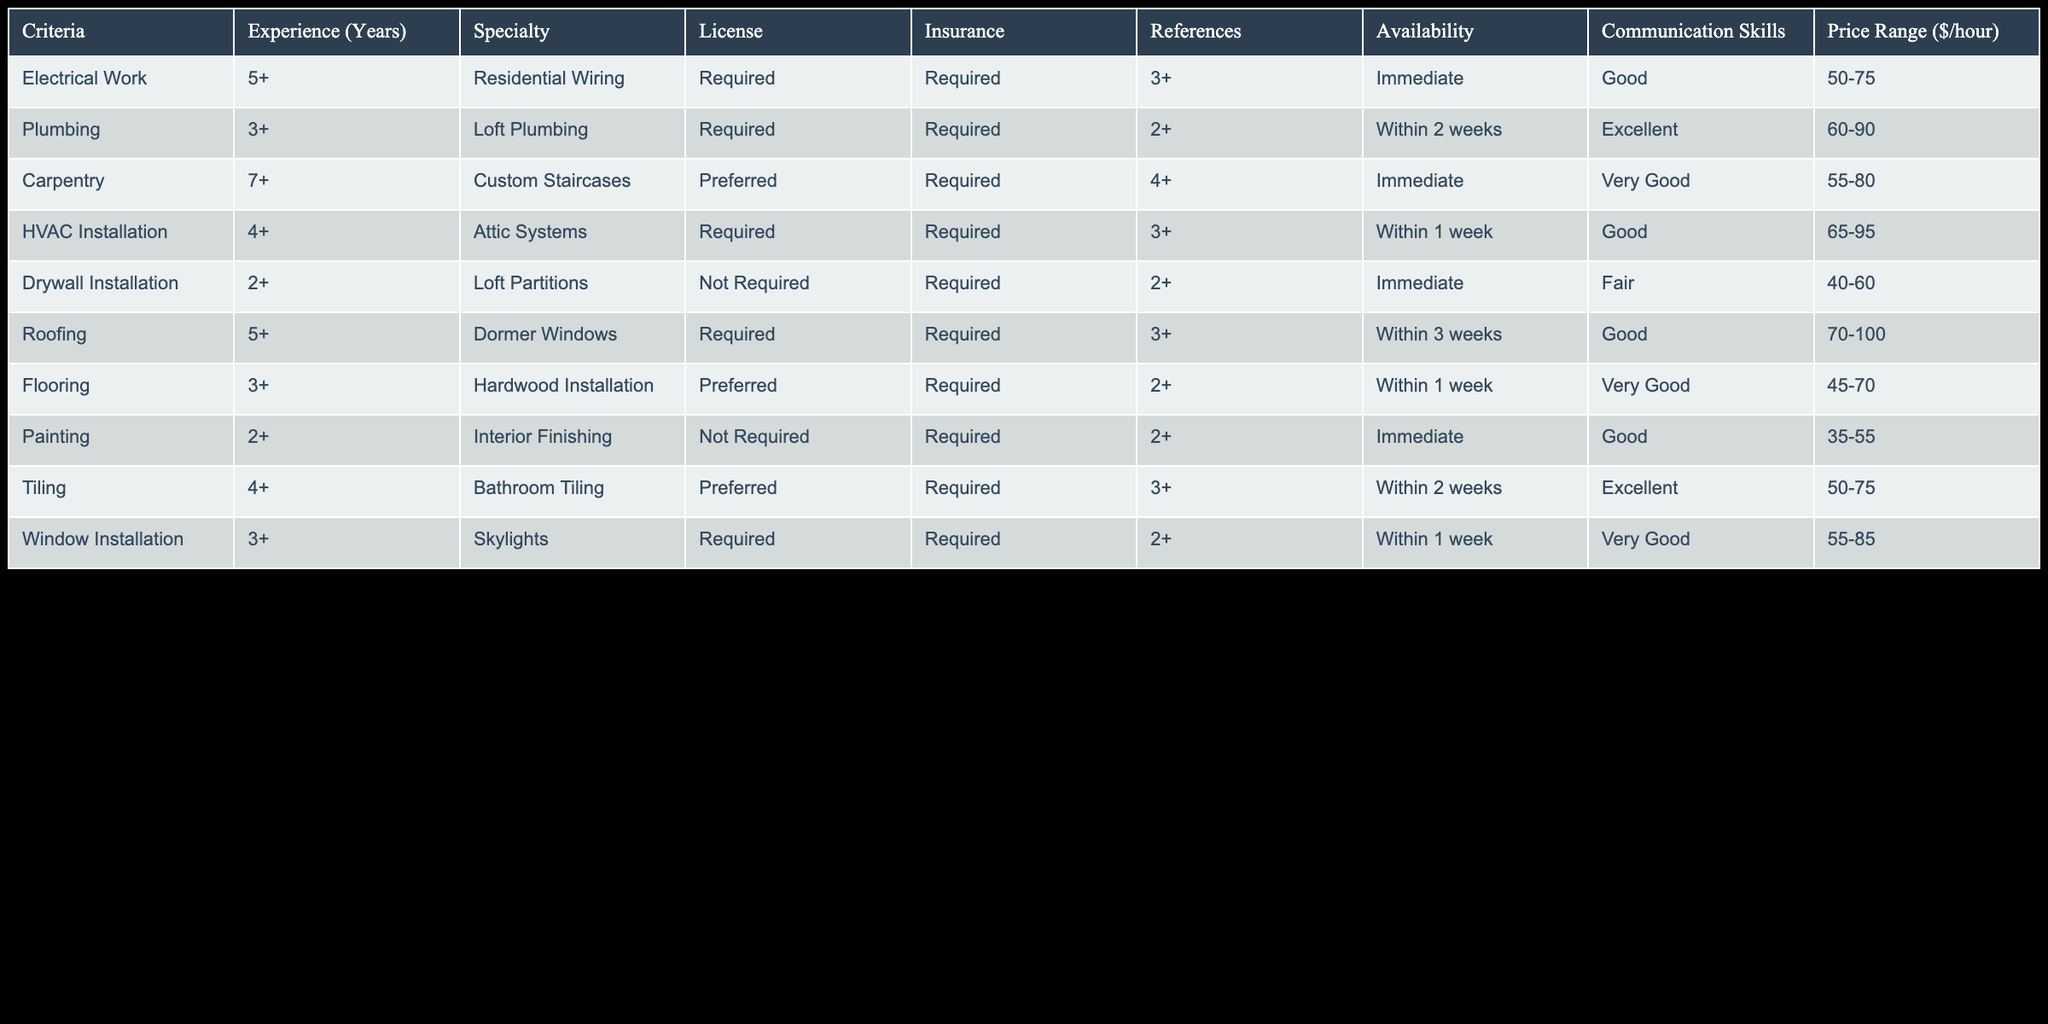What is the price range for Plumbing work? The table indicates that the price range for Plumbing is 60-90 dollars per hour, as listed in the 'Price Range ($/hour)' column corresponding to the 'Plumbing' specialty.
Answer: 60-90 How many years of experience is required for Drywall Installation? The 'Experience (Years)' column for Drywall Installation specifies that 2+ years of experience is required, meaning at least 2 years or more is needed.
Answer: 2+ Is insurance required for Carpentry work? In the 'Insurance' column for Carpentry, it is marked as 'Required,' indicating that a valid insurance is necessary for subcontractors in this field.
Answer: Yes What are the specialties with a required license? By filtering the 'License' column to find 'Required' entries, the specialties are Electrical Work, Plumbing, HVAC Installation, Roofing, Window Installation, and Tiling.
Answer: Electrical Work, Plumbing, HVAC Installation, Roofing, Window Installation, Tiling Which specialty has the highest hourly price range? The price ranges for each specialty can be compared, and 'Roofing' has the highest range of 70-100 dollars per hour. Thus, it is the one with the highest pricing.
Answer: 70-100 What is the average rate for specialties that require immediate availability? The specialties requiring immediate availability are Electrical Work, Carpentry, Drywall Installation, Painting, and Window Installation. Their price ranges are 50-75, 55-80, 40-60, 35-55, and 55-85. Calculating the average: (65 + 67.5 + 50 + 45 + 70)/5 = 59.5, sum of lower values (50+55+40+35+55)/5 = 47.
Answer: 59.5 Does any specialty in the table have an availability within two weeks? By looking under the 'Availability' column, we see that Plumbing and Tiling both have availability listed as 'Within 2 weeks.'
Answer: Yes Which specialty has the most references required? The number of references is evaluated by looking for the maximum value in the 'References' column. Carpentry requires 4+ references, which is the highest in the table.
Answer: Carpentry If a subcontractor specializes in HVAC Installation, how many years of experience do they have? The 'Experience (Years)' column for HVAC Installation indicates that they have at least 4 years of experience.
Answer: 4+ 